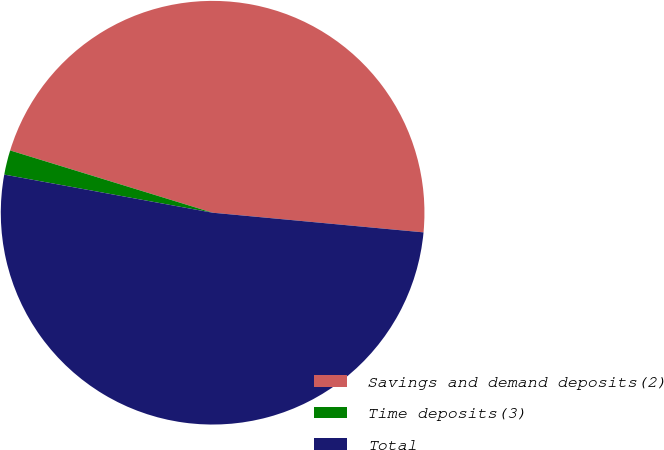<chart> <loc_0><loc_0><loc_500><loc_500><pie_chart><fcel>Savings and demand deposits(2)<fcel>Time deposits(3)<fcel>Total<nl><fcel>46.73%<fcel>1.87%<fcel>51.4%<nl></chart> 